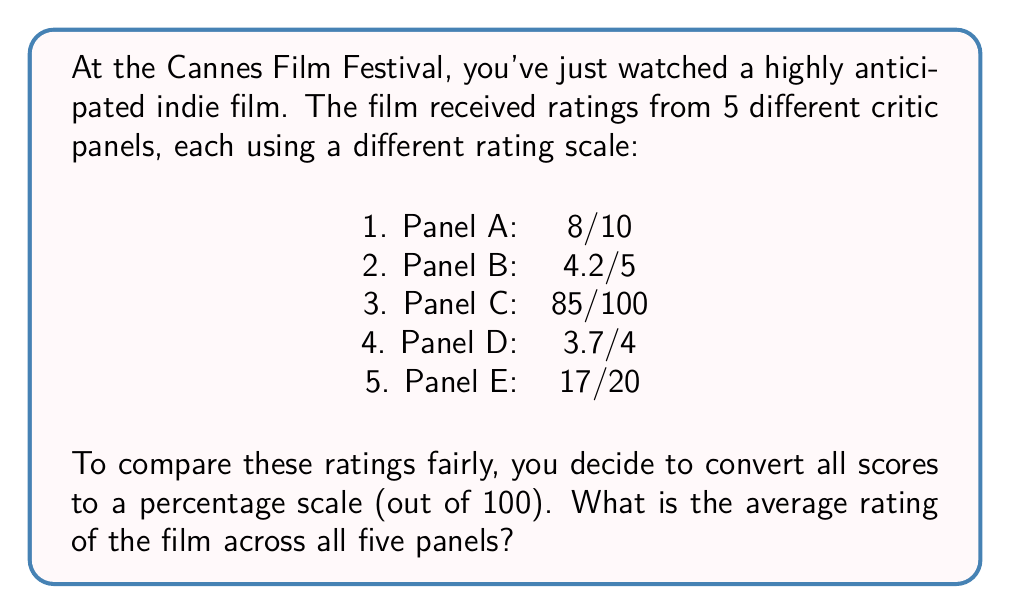Give your solution to this math problem. Let's approach this step-by-step:

1) First, we need to convert each rating to a percentage:

   Panel A: $\frac{8}{10} \times 100 = 80\%$
   Panel B: $\frac{4.2}{5} \times 100 = 84\%$
   Panel C: $\frac{85}{100} \times 100 = 85\%$
   Panel D: $\frac{3.7}{4} \times 100 = 92.5\%$
   Panel E: $\frac{17}{20} \times 100 = 85\%$

2) Now that we have all scores on the same scale, we can calculate the average.

3) To find the average, we sum all the percentages and divide by the number of panels:

   $$\text{Average} = \frac{80 + 84 + 85 + 92.5 + 85}{5}$$

4) Simplifying:

   $$\text{Average} = \frac{426.5}{5} = 85.3\%$$

Therefore, the average rating of the film across all five panels is 85.3%.
Answer: 85.3% 